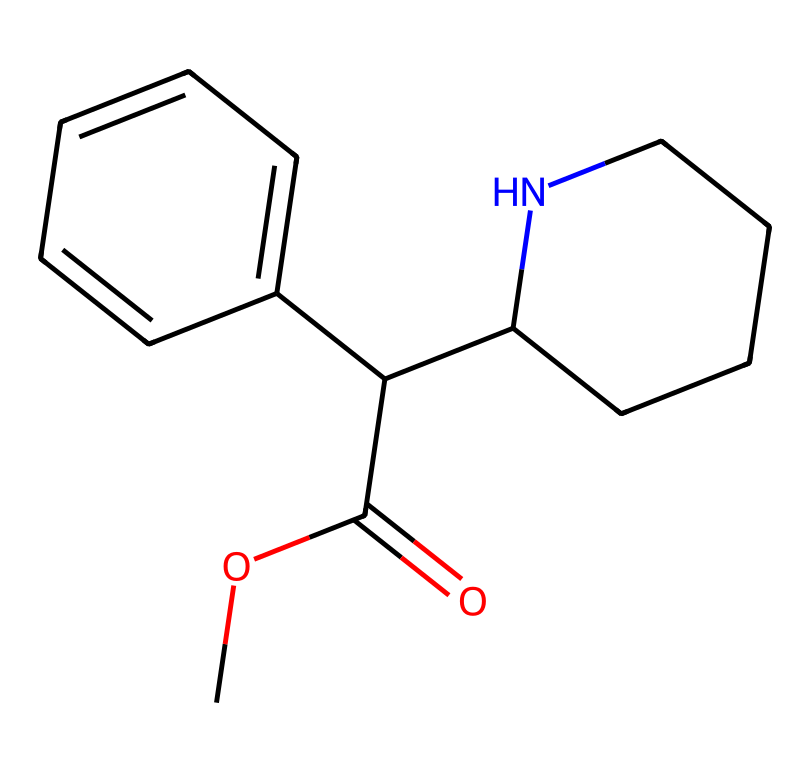What is the molecular formula of methylphenidate? To find the molecular formula, we identify the different types of atoms present in the chemical structure. Counting the carbon (C), hydrogen (H), nitrogen (N), and oxygen (O) atoms gives: 17 carbon atoms, 19 hydrogen atoms, 2 nitrogen atoms, and 2 oxygen atoms. Therefore, the molecular formula is C17H19N2O2.
Answer: C17H19N2O2 How many rings are present in the structure? The structure contains two distinct rings: one is a five-membered ring containing nitrogen (piperidine), and the other is a six-membered aromatic ring (benzene). Therefore, there are 2 rings in total.
Answer: 2 What functional groups are present in methylphenidate? The functional groups present in methylphenidate include an ester group (-COO-) and a secondary amine from the piperidine ring. Identifying these groups will allow us to recognize the chemical properties.
Answer: ester, secondary amine What impact does the aromatic ring have on the properties of methylphenidate? The aromatic ring contributes to the stability of methylphenidate due to resonance, which affects its metabolic stability and how it interacts with biological targets. This structural feature is critical for its function as a medication.
Answer: stability, interactions What is the role of the nitrogen atoms in methylphenidate? The nitrogen atoms in methylphenidate play a crucial role in defining its pharmacological activity. One nitrogen is part of the piperidine ring, which contributes to the drug's ability to interact with neurotransmitter receptors, while the other contributes to the secondary amine character.
Answer: pharmacological activity Does methylphenidate have a chiral center? A chiral center is present when a carbon atom is bonded to four different groups. In the structure of methylphenidate, one of the carbons in the piperidine ring is chiral, meaning it can exist in two configurations (enantiomers).
Answer: yes 